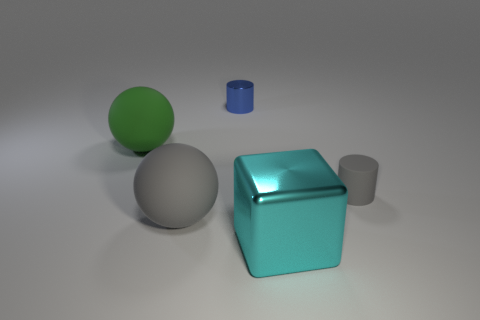What could be the function of the objects? Are they purely decorative? From the image, it's unclear whether the objects serve a functional purpose or are decorative. The simplistic forms – a sphere, a cube, and a cylinder – are often used in educational contexts to demonstrate geometry or in art to study shapes and shading. However, without additional context, it's difficult to determine their specific use in this setting. 